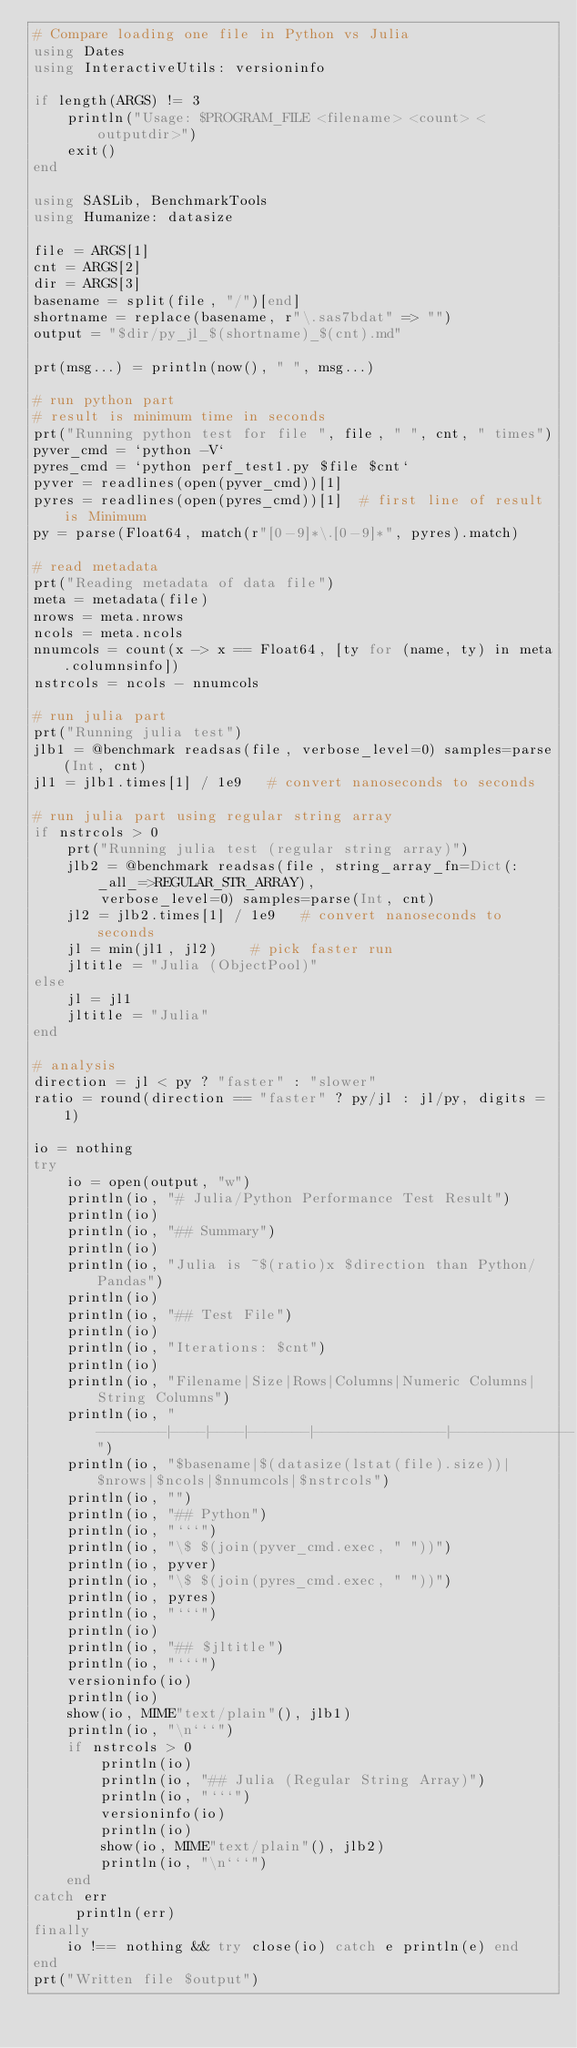<code> <loc_0><loc_0><loc_500><loc_500><_Julia_># Compare loading one file in Python vs Julia
using Dates
using InteractiveUtils: versioninfo

if length(ARGS) != 3
    println("Usage: $PROGRAM_FILE <filename> <count> <outputdir>")
	exit()
end

using SASLib, BenchmarkTools
using Humanize: datasize

file = ARGS[1]
cnt = ARGS[2]
dir = ARGS[3]
basename = split(file, "/")[end]
shortname = replace(basename, r"\.sas7bdat" => "")
output = "$dir/py_jl_$(shortname)_$(cnt).md"

prt(msg...) = println(now(), " ", msg...)

# run python part
# result is minimum time in seconds
prt("Running python test for file ", file, " ", cnt, " times")
pyver_cmd = `python -V`
pyres_cmd = `python perf_test1.py $file $cnt`
pyver = readlines(open(pyver_cmd))[1]
pyres = readlines(open(pyres_cmd))[1]  # first line of result is Minimum
py = parse(Float64, match(r"[0-9]*\.[0-9]*", pyres).match) 

# read metadata
prt("Reading metadata of data file")
meta = metadata(file)
nrows = meta.nrows
ncols = meta.ncols
nnumcols = count(x -> x == Float64, [ty for (name, ty) in meta.columnsinfo])
nstrcols = ncols - nnumcols

# run julia part
prt("Running julia test")
jlb1 = @benchmark readsas(file, verbose_level=0) samples=parse(Int, cnt)
jl1 = jlb1.times[1] / 1e9   # convert nanoseconds to seconds

# run julia part using regular string array
if nstrcols > 0
    prt("Running julia test (regular string array)")
    jlb2 = @benchmark readsas(file, string_array_fn=Dict(:_all_=>REGULAR_STR_ARRAY), 
        verbose_level=0) samples=parse(Int, cnt)
    jl2 = jlb2.times[1] / 1e9   # convert nanoseconds to seconds
    jl = min(jl1, jl2)    # pick faster run
    jltitle = "Julia (ObjectPool)"
else
    jl = jl1
    jltitle = "Julia"
end

# analysis
direction = jl < py ? "faster" : "slower"
ratio = round(direction == "faster" ? py/jl : jl/py, digits = 1)

io = nothing
try
    io = open(output, "w")
    println(io, "# Julia/Python Performance Test Result")
    println(io)
    println(io, "## Summary")
    println(io)
    println(io, "Julia is ~$(ratio)x $direction than Python/Pandas")
    println(io)
    println(io, "## Test File")
    println(io)
    println(io, "Iterations: $cnt")
    println(io)
    println(io, "Filename|Size|Rows|Columns|Numeric Columns|String Columns")
    println(io, "--------|----|----|-------|---------------|--------------")
    println(io, "$basename|$(datasize(lstat(file).size))|$nrows|$ncols|$nnumcols|$nstrcols")
    println(io, "")
    println(io, "## Python")
    println(io, "```")
    println(io, "\$ $(join(pyver_cmd.exec, " "))")
    println(io, pyver)
    println(io, "\$ $(join(pyres_cmd.exec, " "))")
    println(io, pyres)
    println(io, "```")
    println(io)
    println(io, "## $jltitle")
    println(io, "```")
    versioninfo(io)
    println(io)
    show(io, MIME"text/plain"(), jlb1)
    println(io, "\n```")
    if nstrcols > 0
        println(io)
        println(io, "## Julia (Regular String Array)")
        println(io, "```")
        versioninfo(io)
        println(io)
        show(io, MIME"text/plain"(), jlb2)
        println(io, "\n```")
    end
catch err
     println(err)
finally
    io !== nothing && try close(io) catch e println(e) end
end
prt("Written file $output")
</code> 